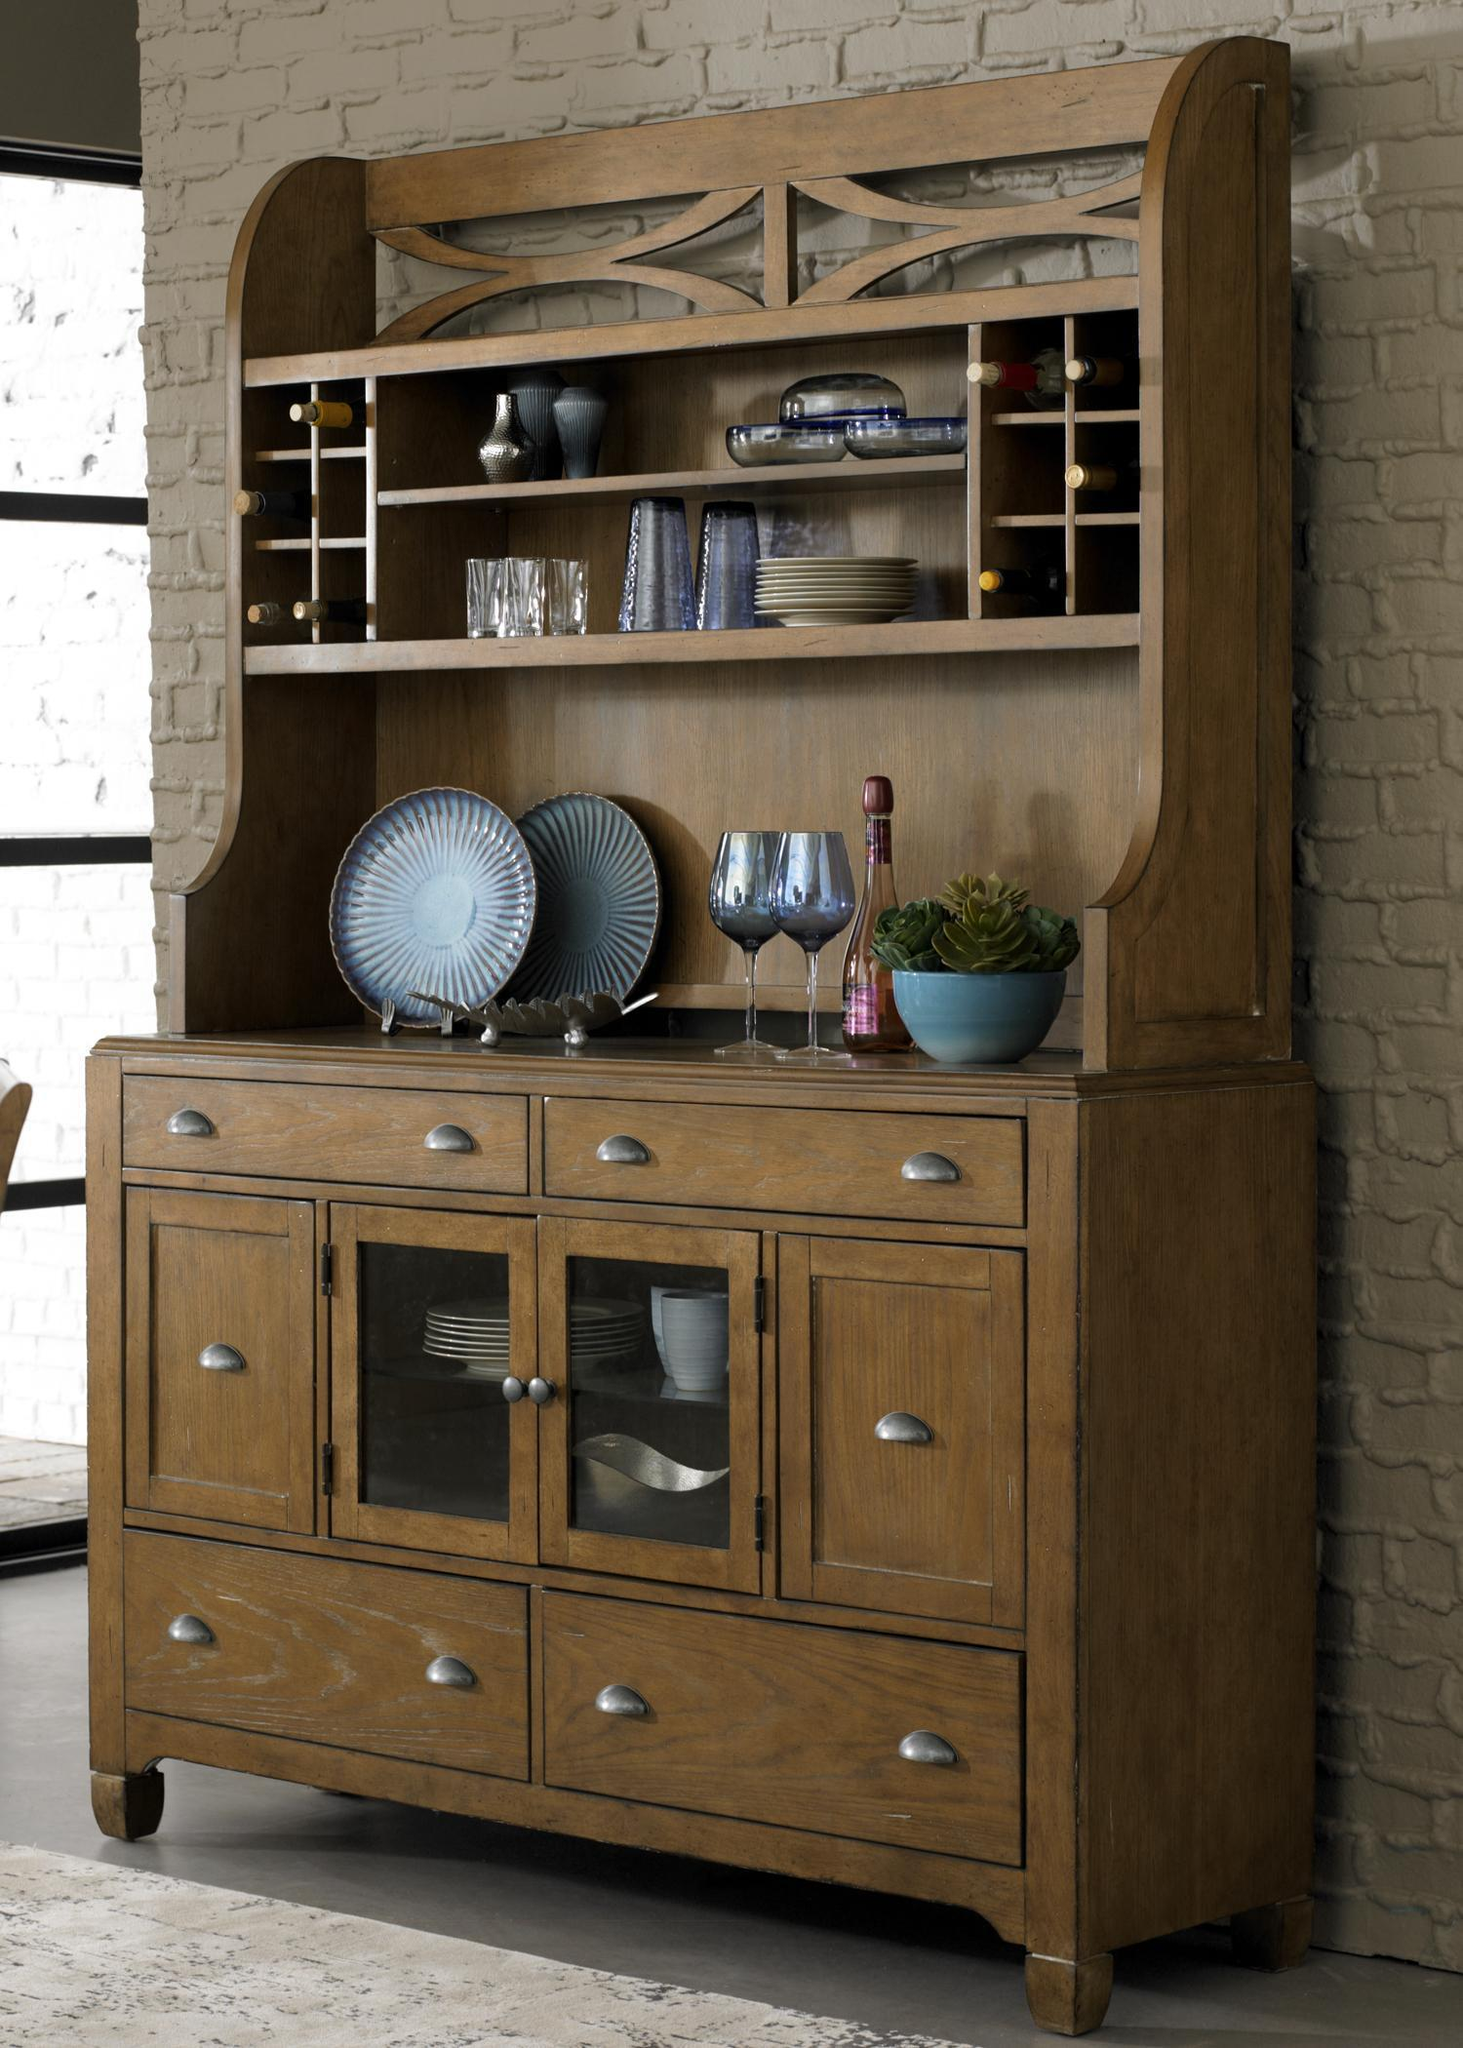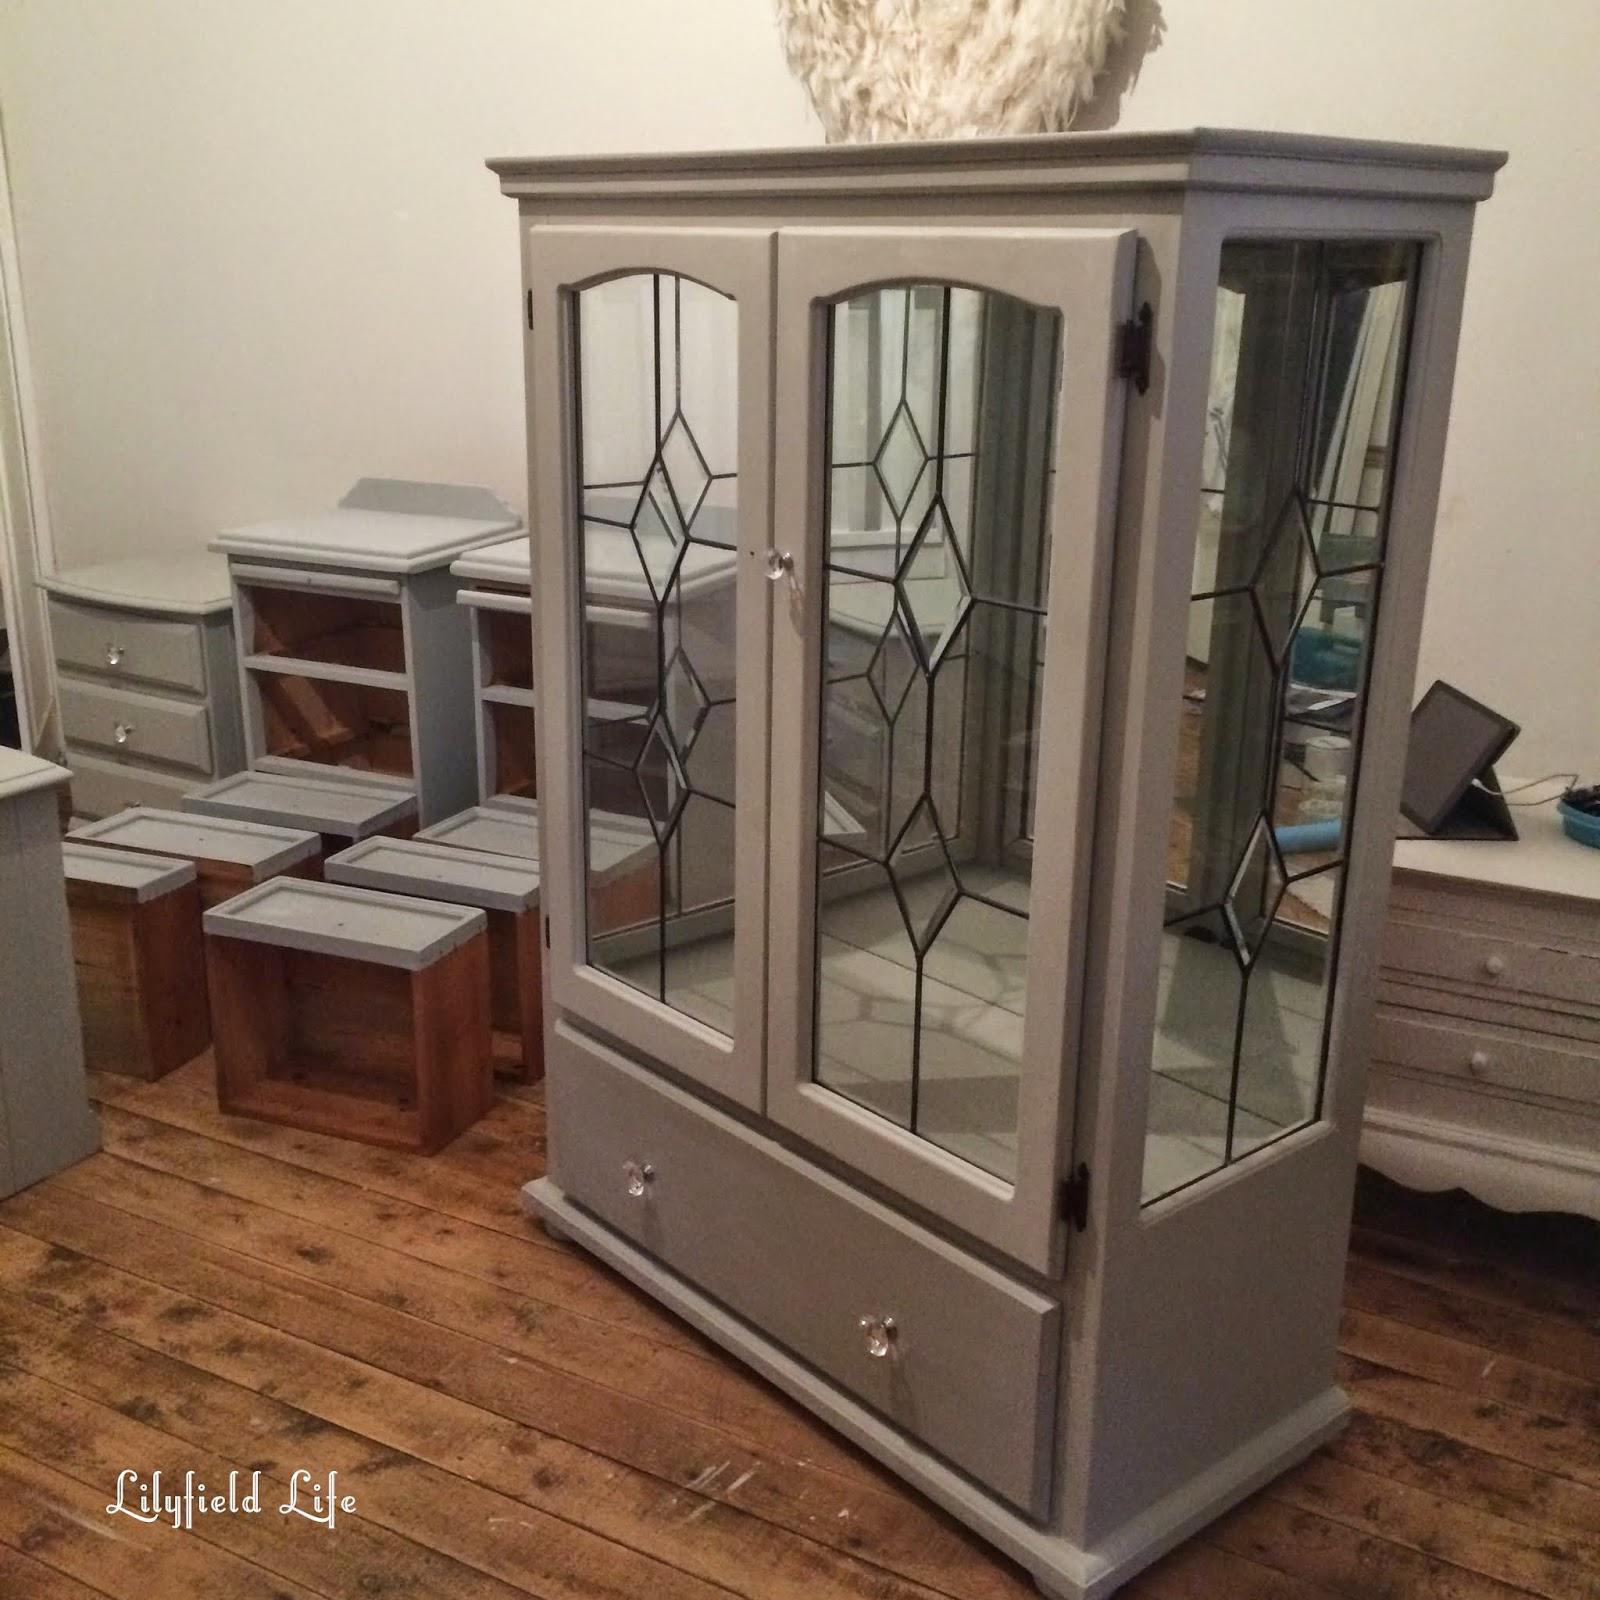The first image is the image on the left, the second image is the image on the right. Evaluate the accuracy of this statement regarding the images: "The cabinet on the left is visibly full of dishes, and the one on the right is not.". Is it true? Answer yes or no. Yes. The first image is the image on the left, the second image is the image on the right. Examine the images to the left and right. Is the description "One of the images includes warm-colored flowers." accurate? Answer yes or no. No. The first image is the image on the left, the second image is the image on the right. Analyze the images presented: Is the assertion "An image shows a flat-topped grayish cabinet with something round on the wall behind it and nothing inside it." valid? Answer yes or no. Yes. The first image is the image on the left, the second image is the image on the right. Given the left and right images, does the statement "A low wooden cabinet in one image is made from the top of a larger hutch, sits on low rounded feet, and has four doors with long arched glass inserts." hold true? Answer yes or no. No. 